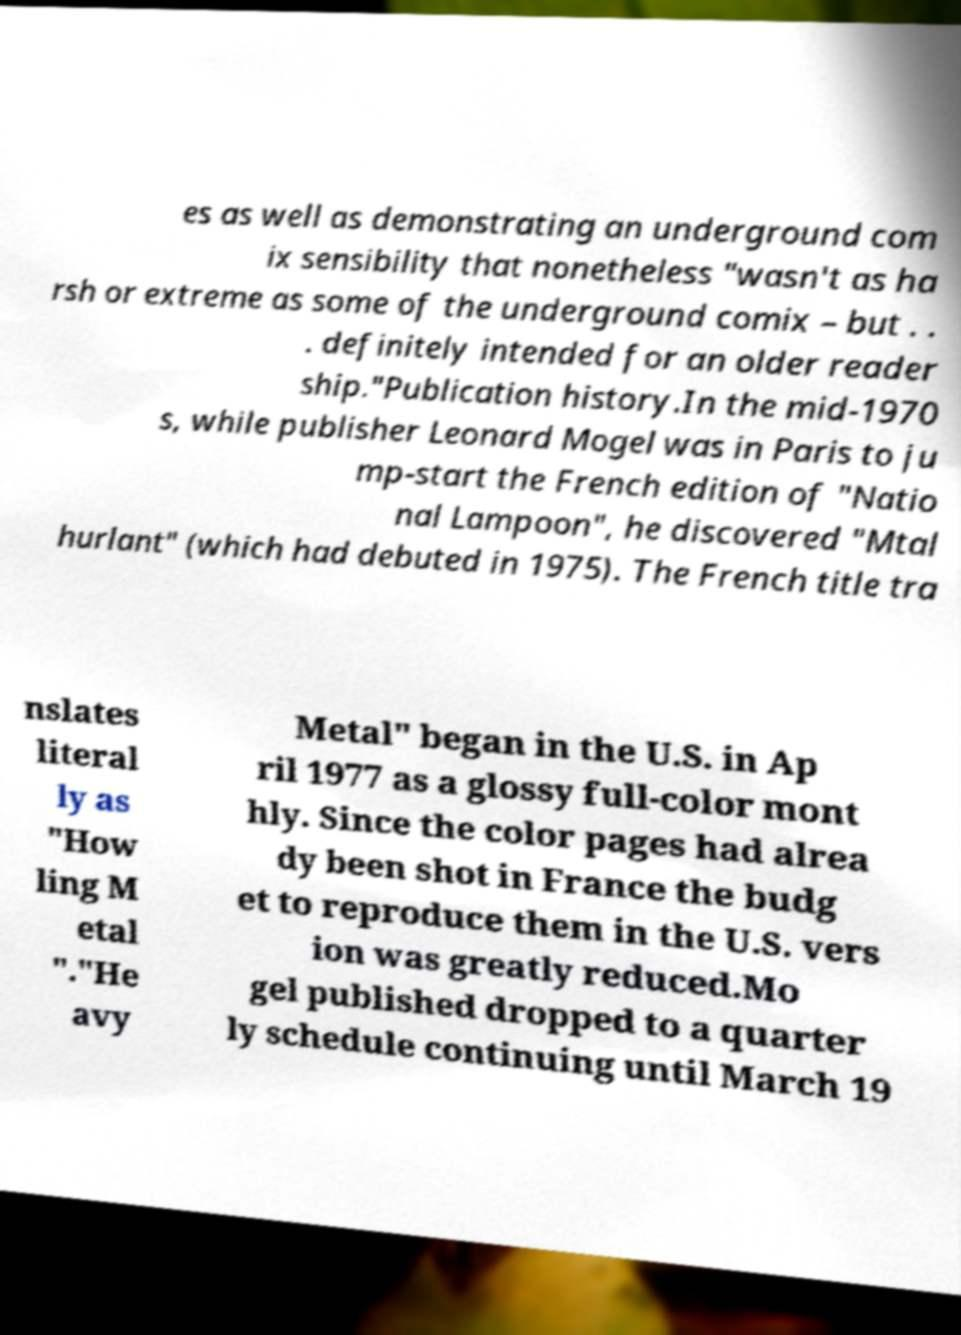For documentation purposes, I need the text within this image transcribed. Could you provide that? es as well as demonstrating an underground com ix sensibility that nonetheless "wasn't as ha rsh or extreme as some of the underground comix – but . . . definitely intended for an older reader ship."Publication history.In the mid-1970 s, while publisher Leonard Mogel was in Paris to ju mp-start the French edition of "Natio nal Lampoon", he discovered "Mtal hurlant" (which had debuted in 1975). The French title tra nslates literal ly as "How ling M etal "."He avy Metal" began in the U.S. in Ap ril 1977 as a glossy full-color mont hly. Since the color pages had alrea dy been shot in France the budg et to reproduce them in the U.S. vers ion was greatly reduced.Mo gel published dropped to a quarter ly schedule continuing until March 19 